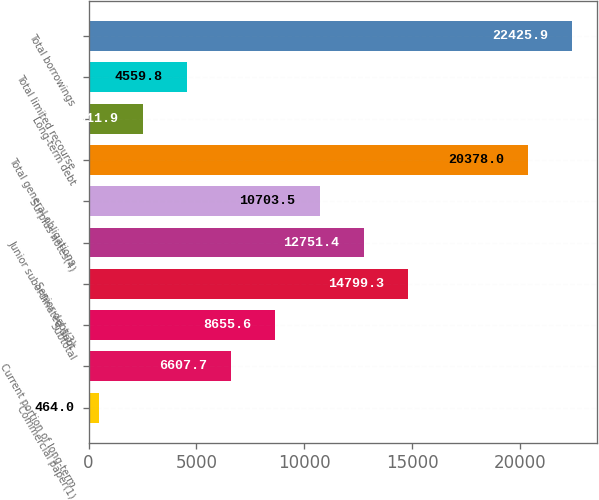Convert chart to OTSL. <chart><loc_0><loc_0><loc_500><loc_500><bar_chart><fcel>Commercial paper(1)<fcel>Current portion of long-term<fcel>Subtotal<fcel>Senior debt(3)<fcel>Junior subordinated debt<fcel>Surplus notes(4)<fcel>Total general obligations<fcel>Long-term debt<fcel>Total limited recourse<fcel>Total borrowings<nl><fcel>464<fcel>6607.7<fcel>8655.6<fcel>14799.3<fcel>12751.4<fcel>10703.5<fcel>20378<fcel>2511.9<fcel>4559.8<fcel>22425.9<nl></chart> 